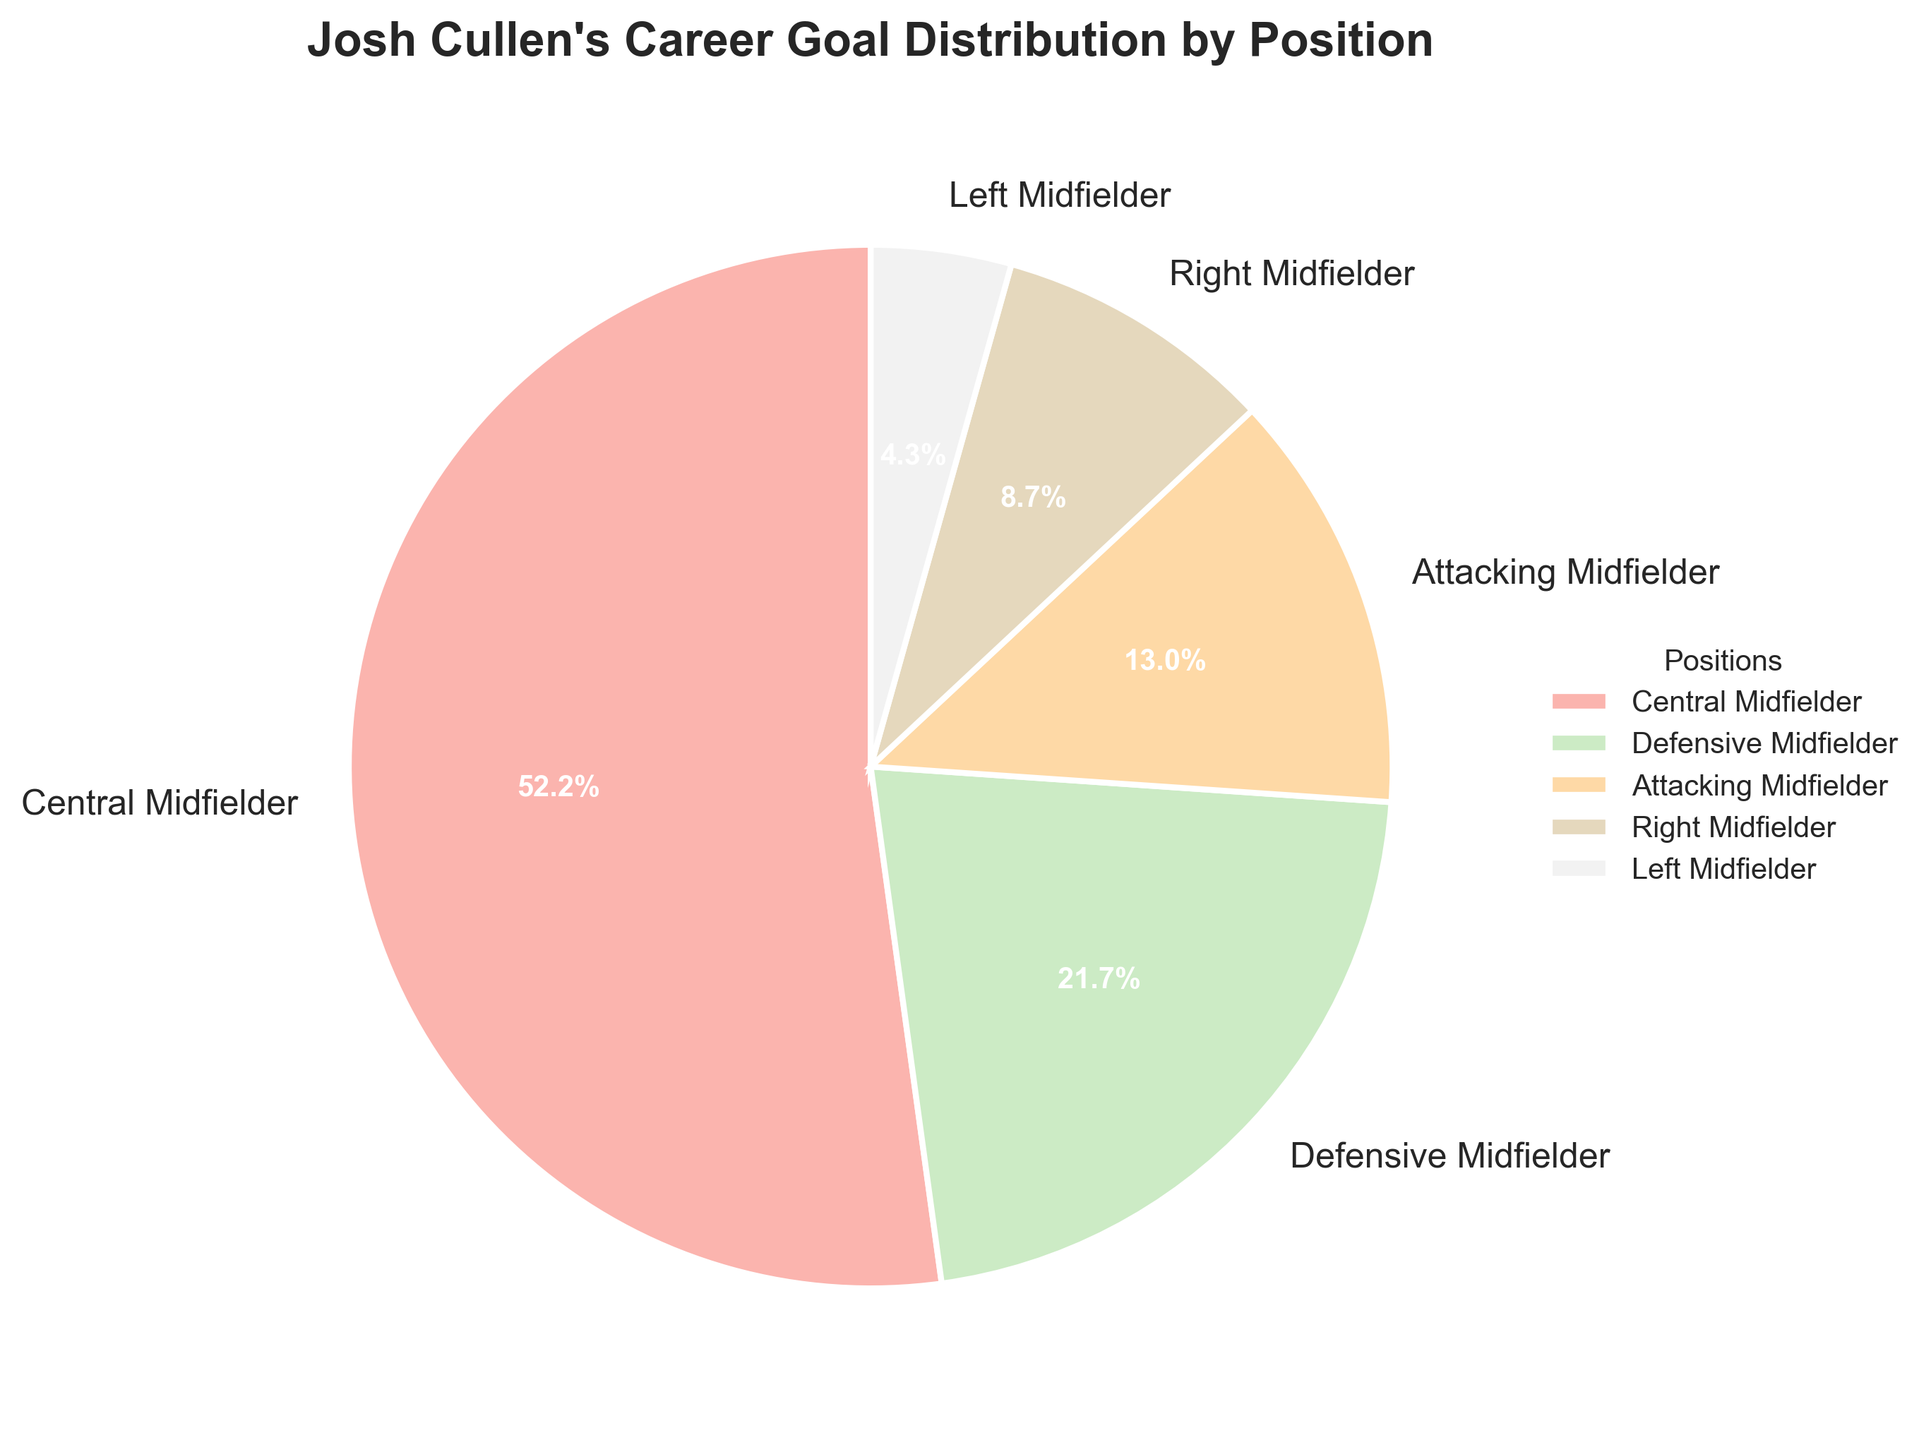which position has the highest percentage of goals? The pie chart visually shows that the 'Central Midfielder' section occupies the largest portion. This indicates that this position has the highest percentage.
Answer: Central Midfielder What is the total number of goals scored by positions other than 'Central Midfielder'? According to the pie chart, 'Defensive Midfielder' has 5 goals, 'Attacking Midfielder' has 3 goals, 'Right Midfielder' has 2 goals, and 'Left Midfielder' has 1 goal. Summing these values: 5 + 3 + 2 + 1 = 11.
Answer: 11 What is the combined percentage of goals scored by 'Attacking Midfielder,' 'Right Midfielder,' and 'Left Midfielder'? The pie chart shows percentages for these positions: 'Attacking Midfielder' (3 goals/23 total goals)*100 ≈ 13%, 'Right Midfielder' (2 goals/23)*100 ≈ 9%, 'Left Midfielder' (1 goal/23)*100 ≈ 4%. Adding these: 13% + 9% + 4% = 26%.
Answer: 26% By how much does the percentage of goals scored by 'Central Midfielder' exceed that by 'Defensive Midfielder'? The pie chart shows that 'Central Midfielder' has (12 goals/23)*100 ≈ 52% and 'Defensive Midfielder' has (5 goals/23)*100 ≈ 22%. The difference is 52% - 22% = 30%.
Answer: 30% Which position contributes the least to Josh Cullen's career goals? The segment with the smallest visual representation in the pie chart corresponds to the 'Left Midfielder' position.
Answer: Left Midfielder How does the percentage of goals scored by 'Right Midfielder' compare to that by 'Defensive Midfielder'? The pie chart shows 'Right Midfielder' with (2 goals/23)*100 ≈ 9% and 'Defensive Midfielder' with (5 goals/23)*100 ≈ 22%. The percentage for 'Right Midfielder' is smaller.
Answer: Smaller If Josh Cullen scored 23 goals in total, what percentage does each position contribute to his total goals? For each position: 'Central Midfielder' (12/23)*100 ≈ 52%, 'Defensive Midfielder' (5/23)*100 ≈ 22%, 'Attacking Midfielder' (3/23)*100 ≈ 13%, 'Right Midfielder' (2/23)*100 ≈ 9%, 'Left Midfielder' (1/23)*100 ≈ 4%.
Answer: Central Midfielder: 52%, Defensive Midfielder: 22%, Attacking Midfielder: 13%, Right Midfielder: 9%, Left Midfielder: 4% What position has more than 10% of the total goals but less than 25%? From the pie chart, 'Defensive Midfielder' has (5 goals/23)*100 ≈ 22%, which is more than 10% but less than 25%.
Answer: Defensive Midfielder 